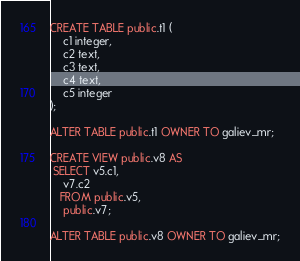Convert code to text. <code><loc_0><loc_0><loc_500><loc_500><_SQL_>CREATE TABLE public.t1 (
    c1 integer,
    c2 text,
    c3 text,
    c4 text,
    c5 integer
);

ALTER TABLE public.t1 OWNER TO galiev_mr;

CREATE VIEW public.v8 AS
 SELECT v5.c1,
    v7.c2
   FROM public.v5,
    public.v7;

ALTER TABLE public.v8 OWNER TO galiev_mr;</code> 